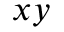<formula> <loc_0><loc_0><loc_500><loc_500>x y</formula> 